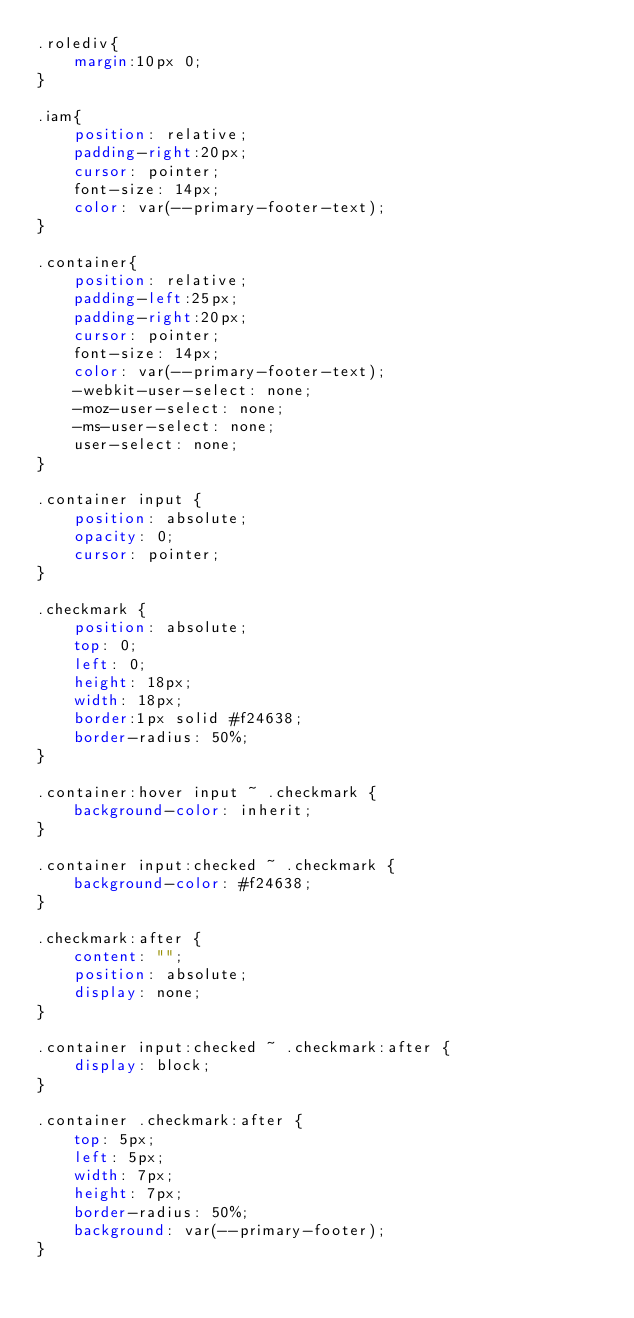<code> <loc_0><loc_0><loc_500><loc_500><_CSS_>.rolediv{
    margin:10px 0;
}

.iam{
    position: relative;
    padding-right:20px;
    cursor: pointer;
    font-size: 14px;
    color: var(--primary-footer-text);
}

.container{
    position: relative;
    padding-left:25px;
    padding-right:20px;
    cursor: pointer;
    font-size: 14px;
    color: var(--primary-footer-text);
    -webkit-user-select: none;
    -moz-user-select: none;
    -ms-user-select: none;
    user-select: none;
}
 
.container input {
    position: absolute;
    opacity: 0;
    cursor: pointer;
}

.checkmark {
    position: absolute;
    top: 0;
    left: 0;
    height: 18px;
    width: 18px;
    border:1px solid #f24638;
    border-radius: 50%;
}

.container:hover input ~ .checkmark {
    background-color: inherit;
}

.container input:checked ~ .checkmark {
    background-color: #f24638;
}

.checkmark:after {
    content: "";
    position: absolute;
    display: none;
}

.container input:checked ~ .checkmark:after {
    display: block;
}

.container .checkmark:after {
    top: 5px;
    left: 5px;
    width: 7px;
    height: 7px;
    border-radius: 50%;
    background: var(--primary-footer);
}</code> 